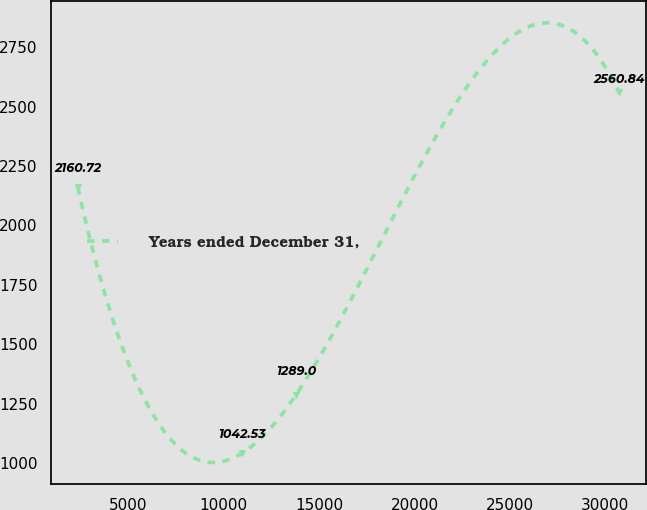Convert chart to OTSL. <chart><loc_0><loc_0><loc_500><loc_500><line_chart><ecel><fcel>Years ended December 31,<nl><fcel>2344.29<fcel>2160.72<nl><fcel>10954.5<fcel>1042.53<nl><fcel>13791.1<fcel>1289<nl><fcel>30710.3<fcel>2560.84<nl></chart> 